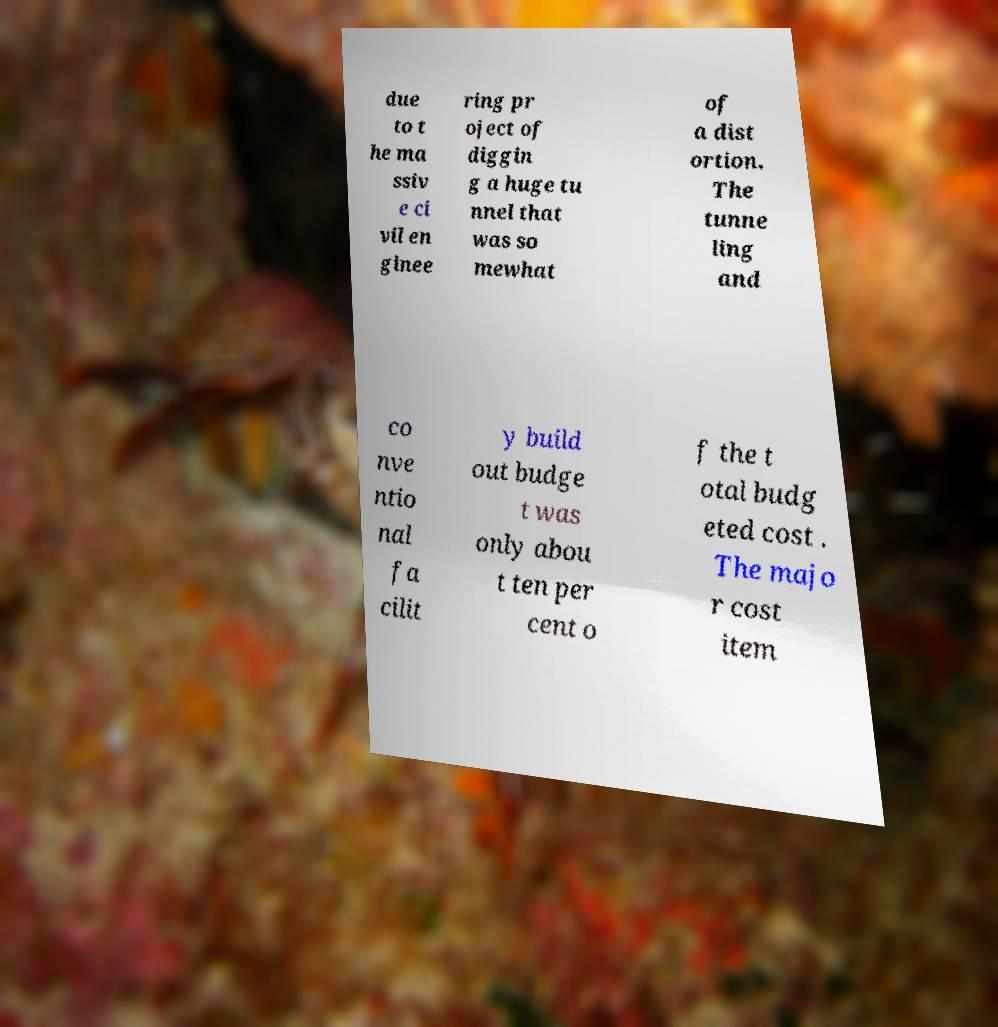Could you assist in decoding the text presented in this image and type it out clearly? due to t he ma ssiv e ci vil en ginee ring pr oject of diggin g a huge tu nnel that was so mewhat of a dist ortion. The tunne ling and co nve ntio nal fa cilit y build out budge t was only abou t ten per cent o f the t otal budg eted cost . The majo r cost item 